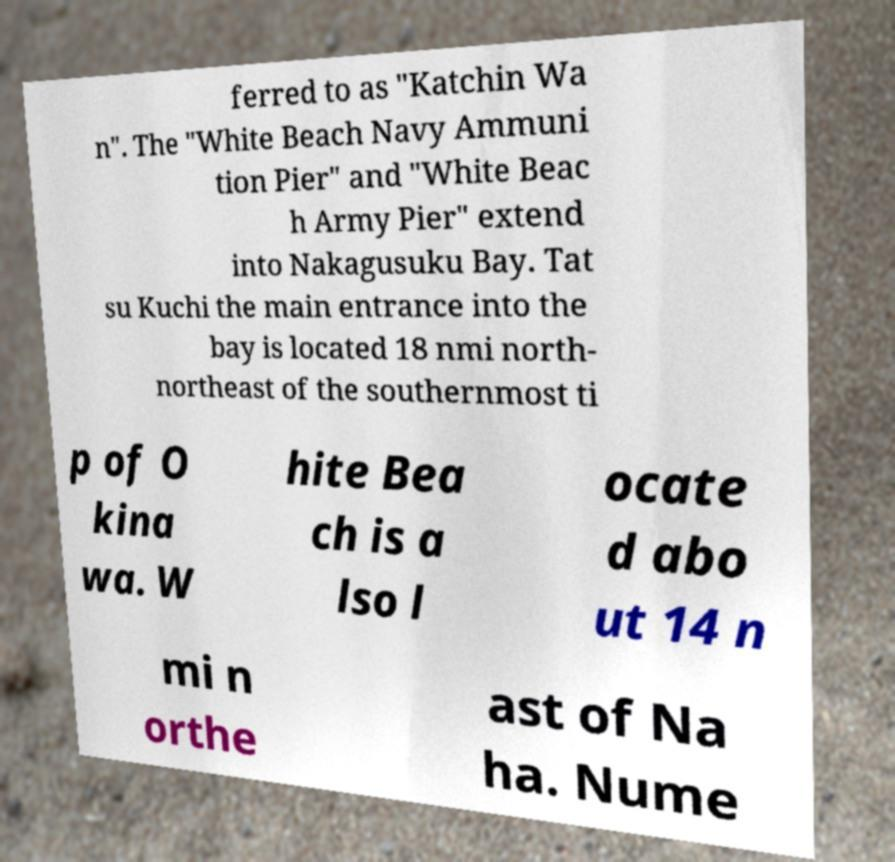Can you read and provide the text displayed in the image?This photo seems to have some interesting text. Can you extract and type it out for me? ferred to as "Katchin Wa n". The "White Beach Navy Ammuni tion Pier" and "White Beac h Army Pier" extend into Nakagusuku Bay. Tat su Kuchi the main entrance into the bay is located 18 nmi north- northeast of the southernmost ti p of O kina wa. W hite Bea ch is a lso l ocate d abo ut 14 n mi n orthe ast of Na ha. Nume 